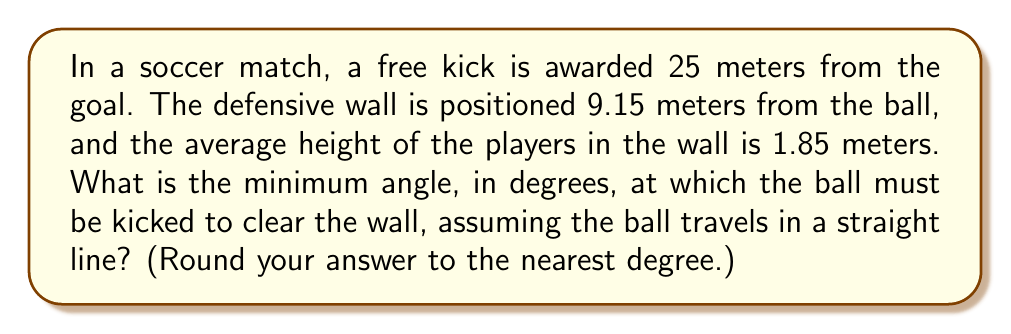Could you help me with this problem? Let's approach this step-by-step:

1) First, we need to visualize the problem. We have a right triangle where:
   - The base is the distance from the wall to the point where the ball would land if it just cleared the wall.
   - The height is the height of the wall (1.85 meters).
   - The hypotenuse is the path of the ball.

2) We can calculate the base of this triangle:
   $$ \text{Base} = 25 - 9.15 = 15.85 \text{ meters} $$

3) Now we have a right triangle with:
   - Adjacent side (base) = 15.85 meters
   - Opposite side (height) = 1.85 meters

4) We need to find the angle between the adjacent side and the hypotenuse. This is given by the arctangent of the opposite side divided by the adjacent side:

   $$ \theta = \arctan(\frac{\text{opposite}}{\text{adjacent}}) = \arctan(\frac{1.85}{15.85}) $$

5) Calculate this:
   $$ \theta = \arctan(0.1167) \approx 6.65^\circ $$

6) Rounding to the nearest degree:
   $$ \theta \approx 7^\circ $$

Therefore, the minimum angle at which the ball must be kicked to clear the wall is approximately 7 degrees.
Answer: $7^\circ$ 